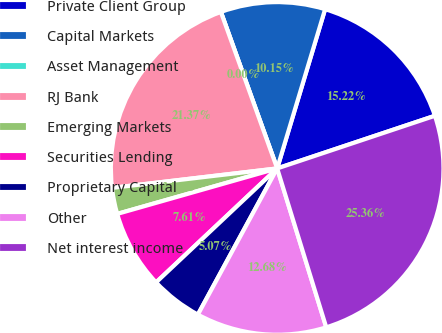Convert chart. <chart><loc_0><loc_0><loc_500><loc_500><pie_chart><fcel>Private Client Group<fcel>Capital Markets<fcel>Asset Management<fcel>RJ Bank<fcel>Emerging Markets<fcel>Securities Lending<fcel>Proprietary Capital<fcel>Other<fcel>Net interest income<nl><fcel>15.22%<fcel>10.15%<fcel>0.0%<fcel>21.37%<fcel>2.54%<fcel>7.61%<fcel>5.07%<fcel>12.68%<fcel>25.36%<nl></chart> 